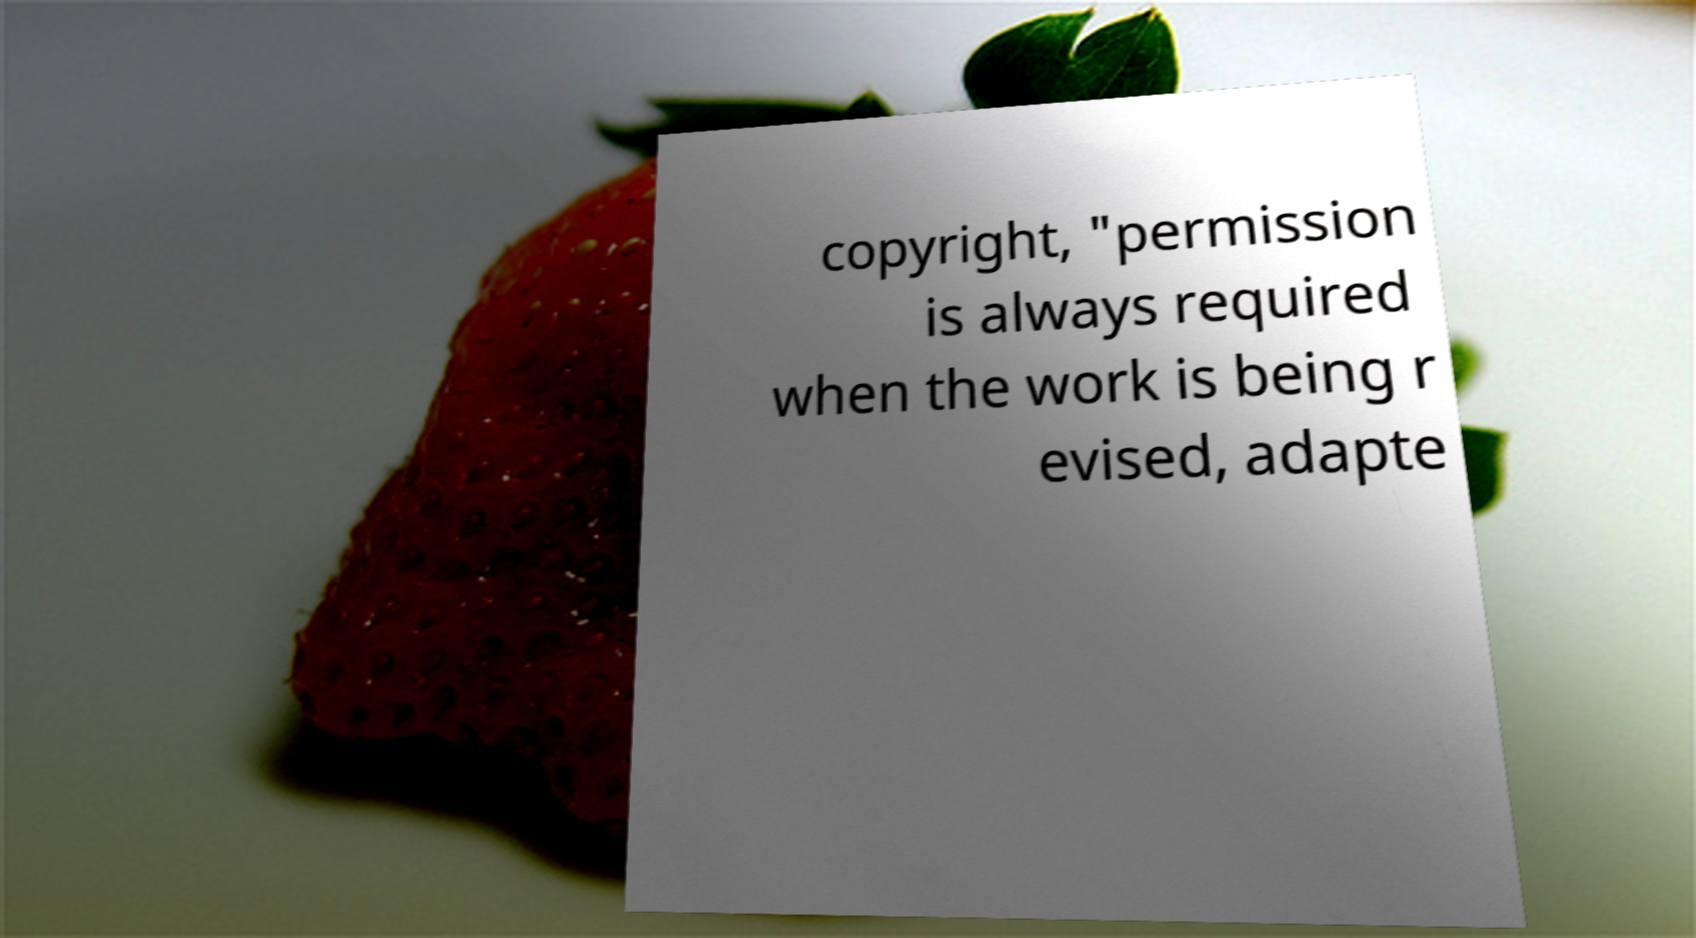Could you assist in decoding the text presented in this image and type it out clearly? copyright, "permission is always required when the work is being r evised, adapte 